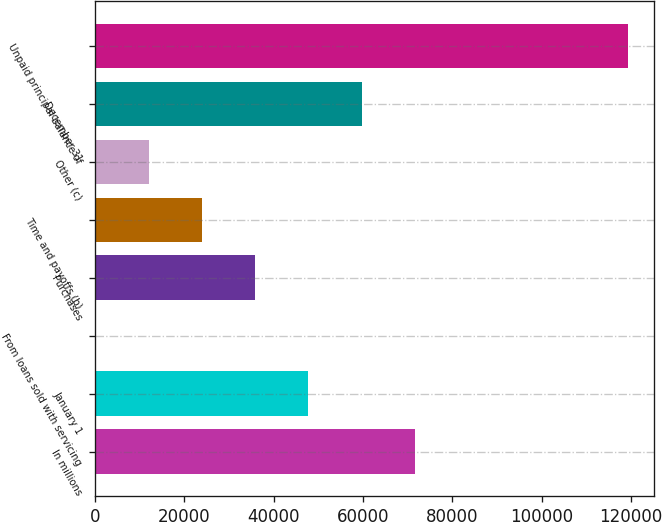Convert chart to OTSL. <chart><loc_0><loc_0><loc_500><loc_500><bar_chart><fcel>In millions<fcel>January 1<fcel>From loans sold with servicing<fcel>Purchases<fcel>Time and payoffs (b)<fcel>Other (c)<fcel>December 31<fcel>Unpaid principal balance of<nl><fcel>71604<fcel>47775<fcel>117<fcel>35860.5<fcel>23946<fcel>12031.5<fcel>59689.5<fcel>119262<nl></chart> 